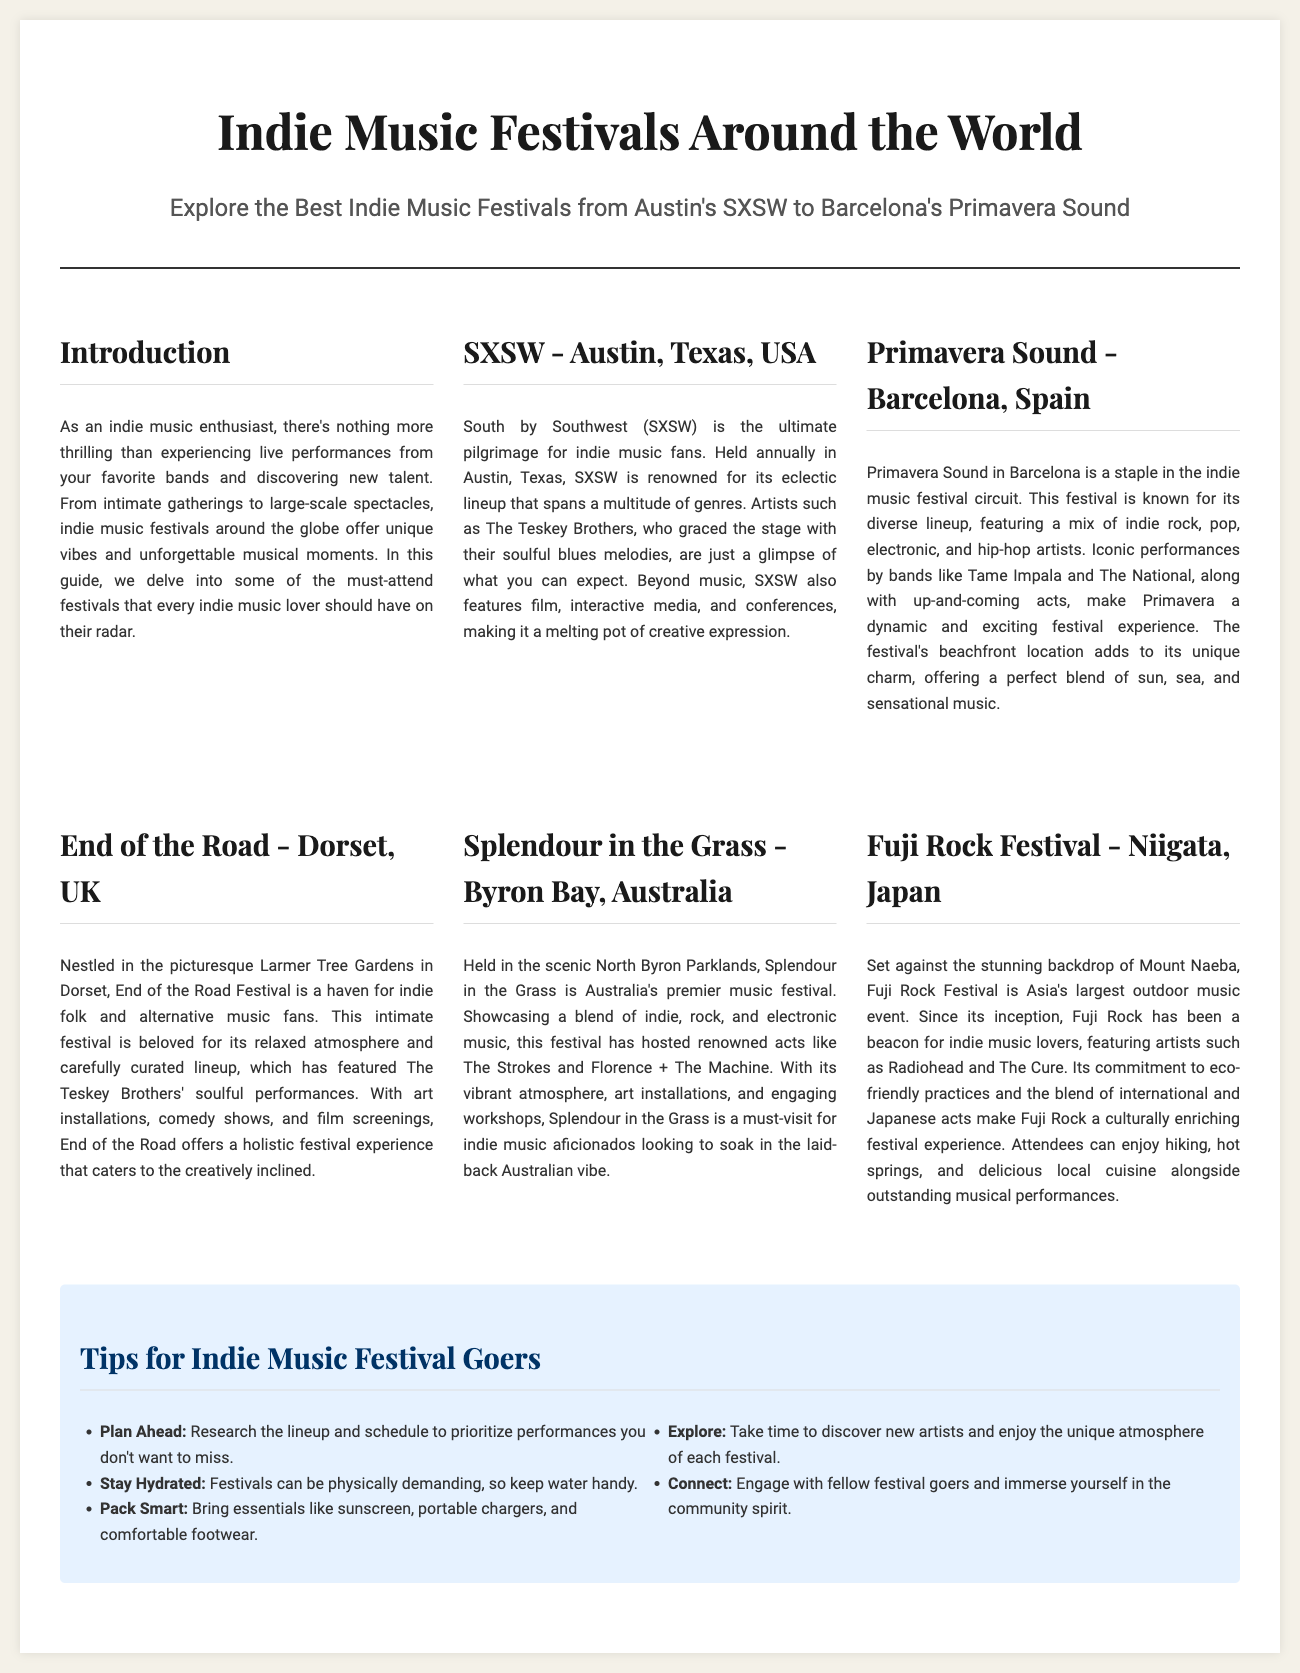What is the title of the document? The title of the document is indicated at the top of the layout.
Answer: Indie Music Festivals Around the World Which festival is held in Austin, Texas? The document specifically mentions the location associated with SXSW.
Answer: SXSW What genre of music is primarily featured at End of the Road Festival? The document describes the type of music associated with this festival.
Answer: Indie folk Name an artist who performed at Primavera Sound. The document lists several artists associated with this festival.
Answer: Tame Impala What unique aspect does Fuji Rock Festival emphasize? The document highlights a distinctive feature of this festival related to its practices.
Answer: Eco-friendly How many tips for festival goers are provided in the document? The document specifies the number of tips listed under the tips section.
Answer: Five What type of atmosphere is mentioned for Splendour in the Grass? The document describes the feeling or vibe of this festival.
Answer: Vibrant Which year is implied in the context of annual festivals? The document refers to festivals occurring every year without specifying a date.
Answer: Annual 